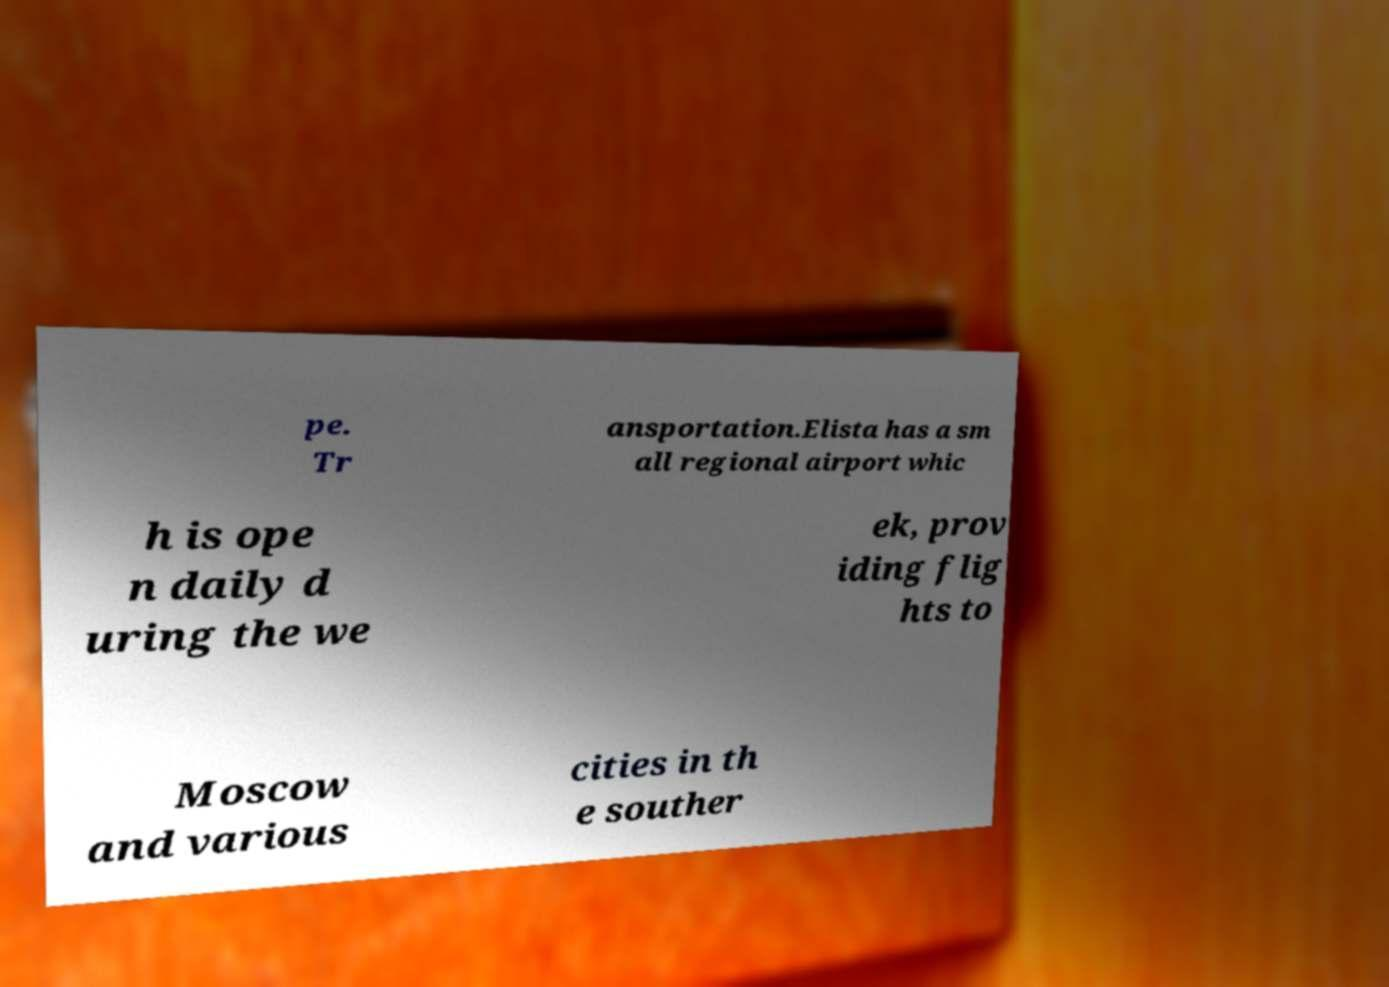Could you assist in decoding the text presented in this image and type it out clearly? pe. Tr ansportation.Elista has a sm all regional airport whic h is ope n daily d uring the we ek, prov iding flig hts to Moscow and various cities in th e souther 